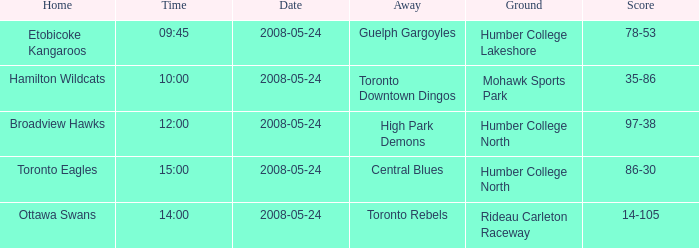Who was the home team of the game at the time of 15:00? Toronto Eagles. 